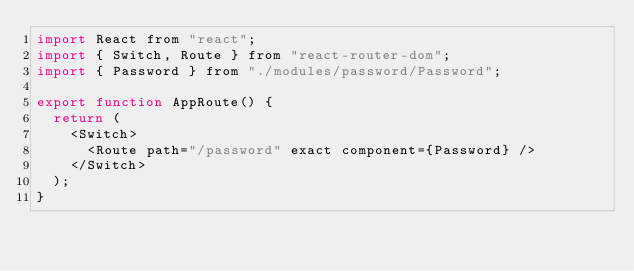<code> <loc_0><loc_0><loc_500><loc_500><_JavaScript_>import React from "react";
import { Switch, Route } from "react-router-dom";
import { Password } from "./modules/password/Password";

export function AppRoute() {
  return (
    <Switch>
      <Route path="/password" exact component={Password} />
    </Switch>
  );
}
</code> 